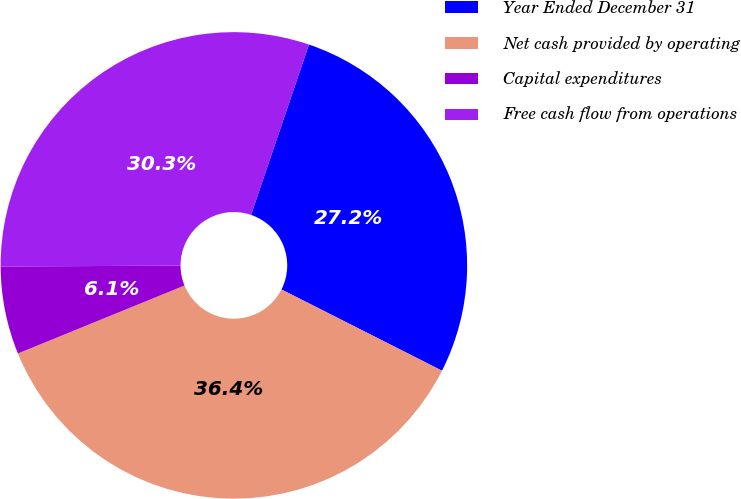Convert chart to OTSL. <chart><loc_0><loc_0><loc_500><loc_500><pie_chart><fcel>Year Ended December 31<fcel>Net cash provided by operating<fcel>Capital expenditures<fcel>Free cash flow from operations<nl><fcel>27.24%<fcel>36.38%<fcel>6.09%<fcel>30.29%<nl></chart> 